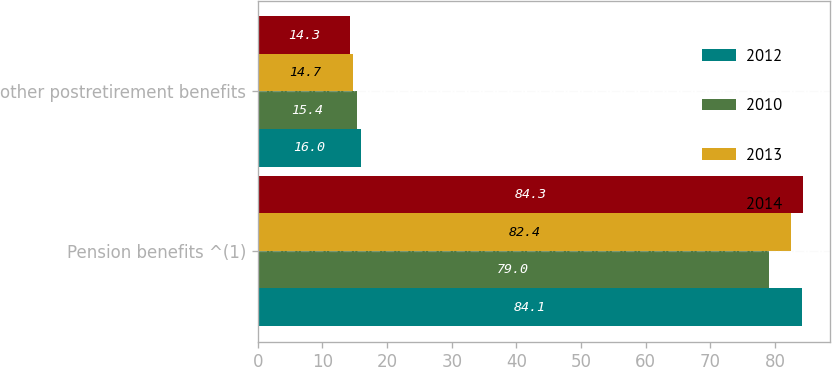Convert chart to OTSL. <chart><loc_0><loc_0><loc_500><loc_500><stacked_bar_chart><ecel><fcel>Pension benefits ^(1)<fcel>other postretirement benefits<nl><fcel>2012<fcel>84.1<fcel>16<nl><fcel>2010<fcel>79<fcel>15.4<nl><fcel>2013<fcel>82.4<fcel>14.7<nl><fcel>2014<fcel>84.3<fcel>14.3<nl></chart> 